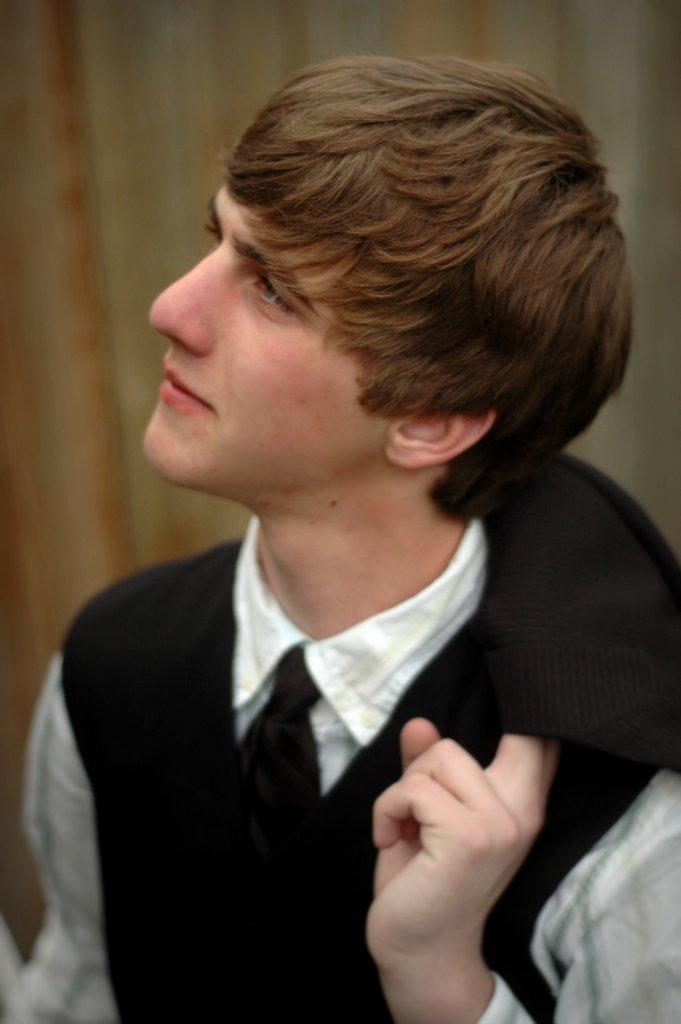What can be seen in the image? There is a person in the image. What is the person wearing? The person is wearing a black color jacket. What is the person holding in their hand? The person is holding a cloth. What is the person doing in the image? The person is watching something. How would you describe the background of the image? The background of the image is blurred. What type of mint is growing in the background of the image? There is no mint present in the image; the background is blurred. 